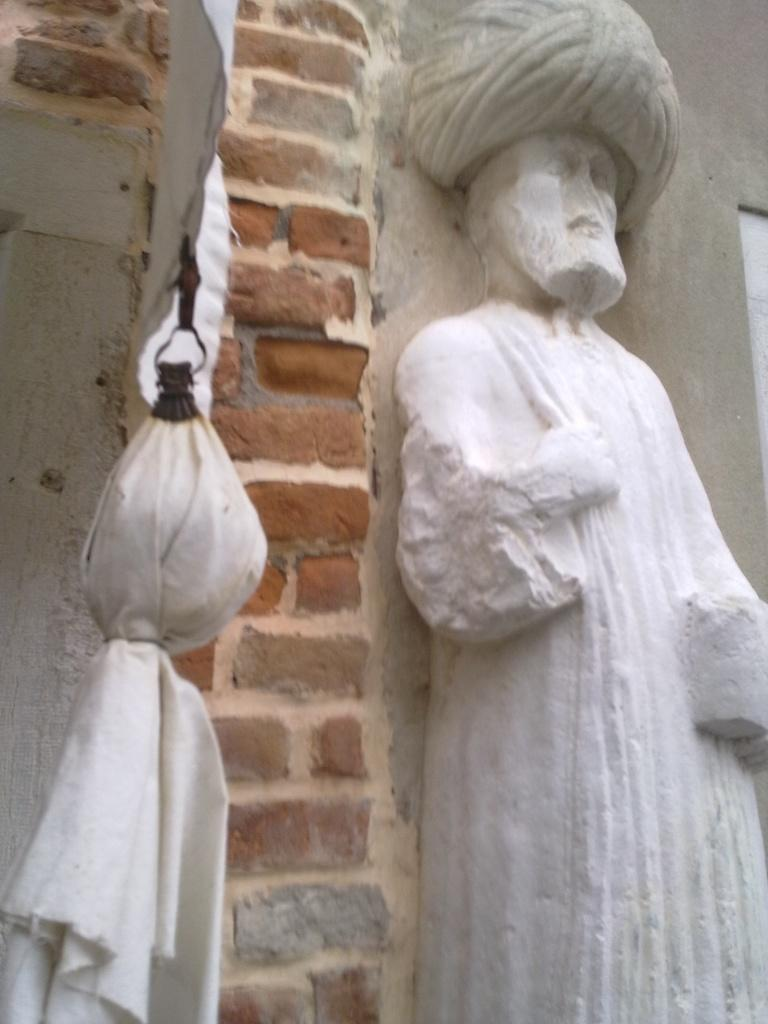What is the main subject in the image? There is a person statue in the image. What is located behind the person statue? There is a wall in the image. What is placed in front of the person statue? There is a white color cloth in front in the image. Can you see any coast, blood, or rings in the image? No, there is no coast, blood, or rings present in the image. 